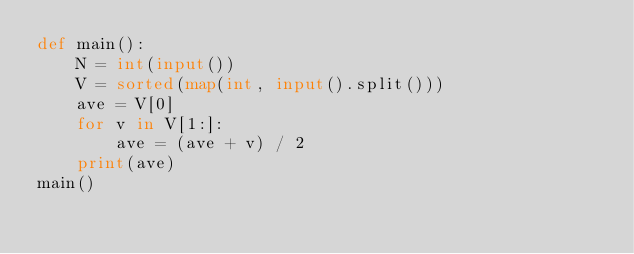<code> <loc_0><loc_0><loc_500><loc_500><_Python_>def main():
    N = int(input())
    V = sorted(map(int, input().split()))
    ave = V[0]
    for v in V[1:]:
        ave = (ave + v) / 2
    print(ave)
main()</code> 